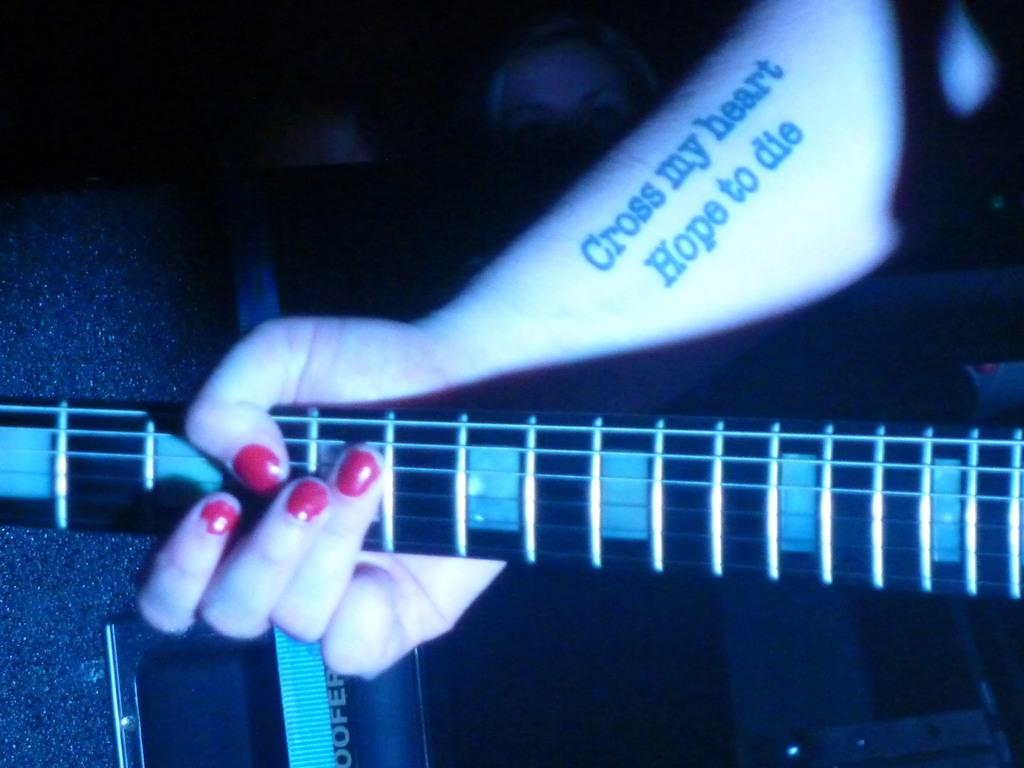What is the person in the image holding? The person is holding a guitar in the image. Can you describe the other person in the image? There is a woman in the image. What time of day might the image have been taken? The image may have been taken during the night, as it appears to be dark. Where might the scene be taking place? The scene appears to be on a stage. What type of cloud can be seen in the image? There are no clouds visible in the image, as it appears to be taken during the night. 